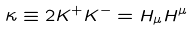Convert formula to latex. <formula><loc_0><loc_0><loc_500><loc_500>\kappa \equiv 2 K ^ { + } K ^ { - } = H _ { \mu } H ^ { \mu }</formula> 